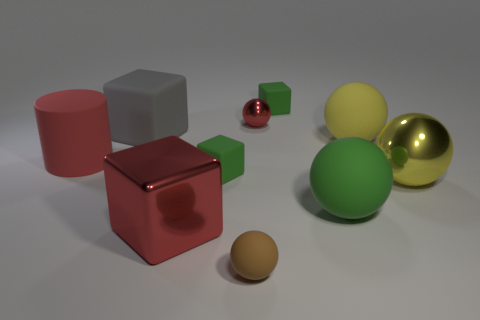Are any tiny matte cubes visible?
Your answer should be very brief. Yes. The sphere that is on the left side of the green sphere and in front of the yellow metallic object is made of what material?
Provide a short and direct response. Rubber. Are there more rubber cubes that are left of the tiny brown thing than tiny red metal things on the right side of the gray block?
Offer a very short reply. Yes. Is there a matte object of the same size as the red metallic ball?
Provide a succinct answer. Yes. There is a green matte object that is to the right of the small matte thing right of the small brown thing that is to the right of the red metal cube; what is its size?
Offer a terse response. Large. The large metallic block has what color?
Offer a very short reply. Red. Is the number of large rubber objects that are to the left of the large green sphere greater than the number of large green things?
Ensure brevity in your answer.  Yes. How many gray blocks are on the right side of the large green thing?
Give a very brief answer. 0. The big thing that is the same color as the matte cylinder is what shape?
Provide a succinct answer. Cube. There is a green thing that is in front of the small cube that is left of the tiny shiny thing; is there a red object right of it?
Provide a short and direct response. No. 